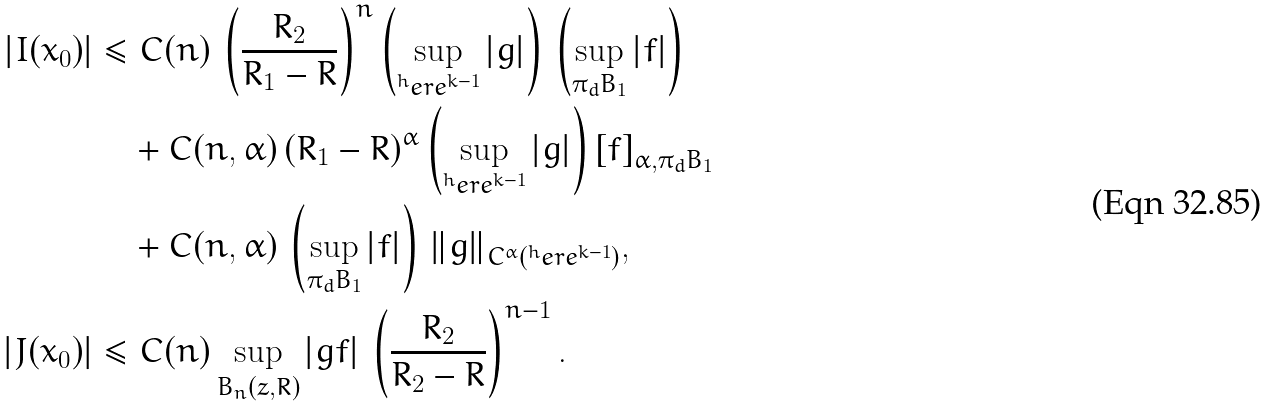Convert formula to latex. <formula><loc_0><loc_0><loc_500><loc_500>| I ( x _ { 0 } ) | & \leq C ( n ) \, \left ( \frac { R _ { 2 } } { R _ { 1 } - R } \right ) ^ { n } \left ( \sup _ { ^ { h } e r e ^ { k - 1 } } | g | \right ) \, \left ( \sup _ { \pi _ { d } B _ { 1 } } | f | \right ) \\ & \quad + C ( n , \alpha ) \, ( R _ { 1 } - R ) ^ { \alpha } \left ( \sup _ { ^ { h } e r e ^ { k - 1 } } | g | \right ) \left [ f \right ] _ { \alpha , \pi _ { d } B _ { 1 } } \\ & \quad + C ( n , \alpha ) \, \left ( \sup _ { \pi _ { d } B _ { 1 } } | f | \right ) \, \| g \| _ { C ^ { \alpha } ( ^ { h } e r e ^ { k - 1 } ) } , \\ | J ( x _ { 0 } ) | & \leq C ( n ) \sup _ { B _ { n } ( z , R ) } | g f | \, \left ( \frac { R _ { 2 } } { R _ { 2 } - R } \right ) ^ { n - 1 } .</formula> 